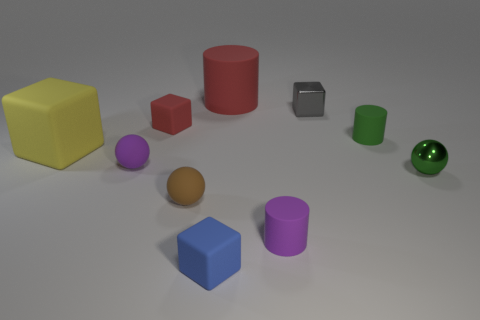What shape is the tiny object that is the same color as the metal ball?
Provide a succinct answer. Cylinder. Do the yellow object and the tiny brown object have the same shape?
Offer a terse response. No. What number of big purple metallic objects are the same shape as the green shiny thing?
Provide a succinct answer. 0. How many small cylinders are to the left of the tiny gray shiny block?
Your response must be concise. 1. Is the color of the tiny cylinder behind the big cube the same as the large block?
Give a very brief answer. No. How many other matte objects are the same size as the yellow rubber object?
Give a very brief answer. 1. There is a yellow object that is made of the same material as the purple sphere; what shape is it?
Offer a very short reply. Cube. Are there any small rubber cubes of the same color as the shiny sphere?
Ensure brevity in your answer.  No. What material is the small brown ball?
Offer a very short reply. Rubber. What number of objects are either brown objects or cyan cubes?
Give a very brief answer. 1. 